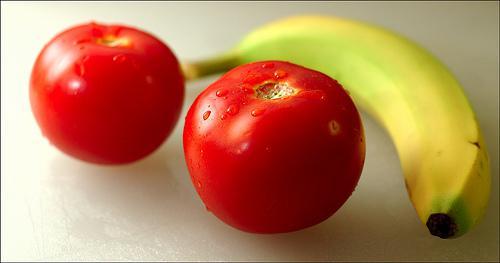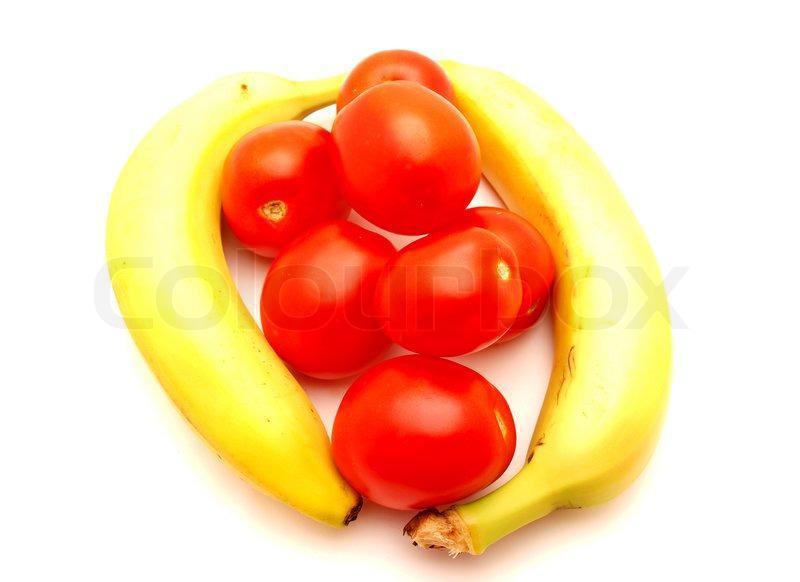The first image is the image on the left, the second image is the image on the right. Examine the images to the left and right. Is the description "An image shows at least one banana posed with at least six red tomatoes, and no other produce items." accurate? Answer yes or no. Yes. The first image is the image on the left, the second image is the image on the right. Evaluate the accuracy of this statement regarding the images: "In one image, at least one banana is lying flat in an arrangement with at least seven red tomatoes that do not have any stems.". Is it true? Answer yes or no. Yes. 